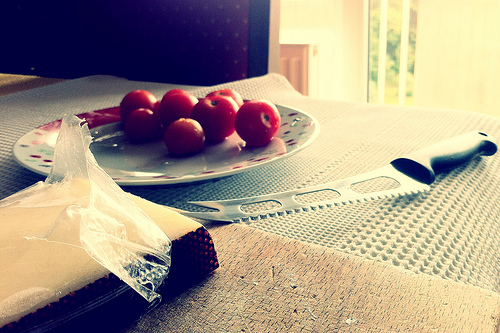<image>
Is the plate next to the knife? Yes. The plate is positioned adjacent to the knife, located nearby in the same general area. 